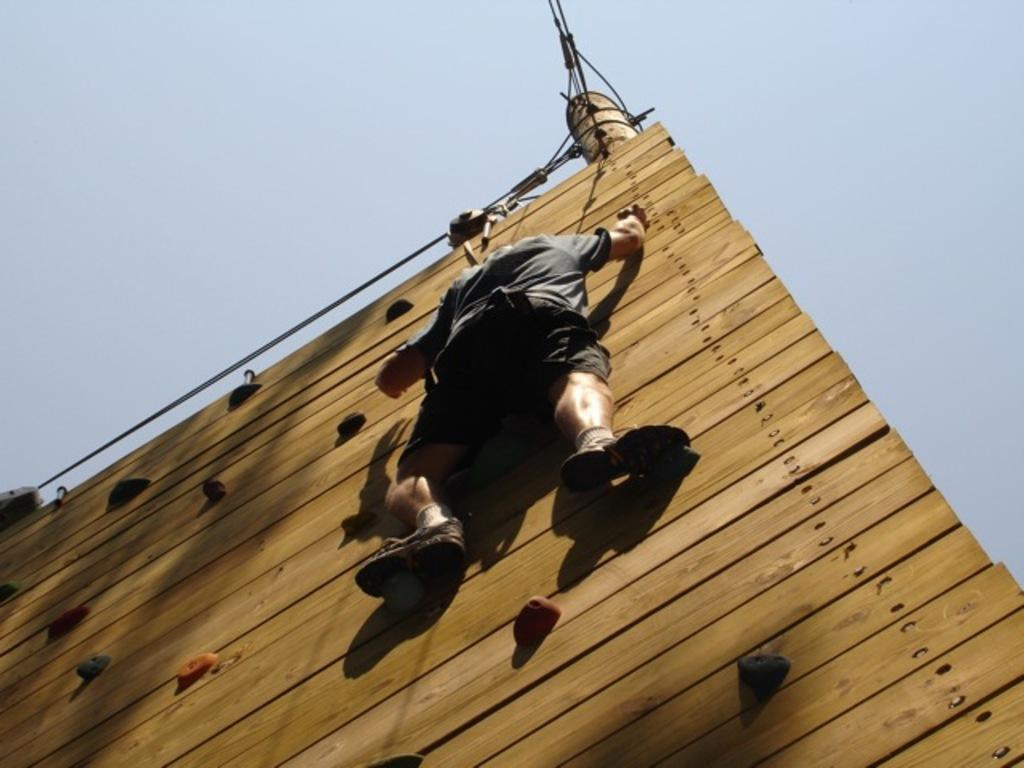Who is the main subject in the image? There is a man in the image. What is the man doing in the image? The man is climbing a wooden wall. What can be seen in the background of the image? The sky is visible in the background of the image. What type of science is the man studying while climbing the wall in the image? There is no indication in the image that the man is studying any type of science while climbing the wall. 